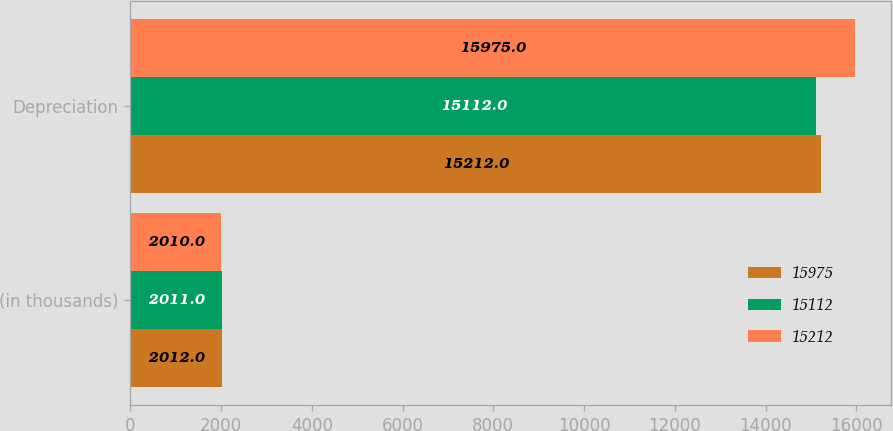Convert chart to OTSL. <chart><loc_0><loc_0><loc_500><loc_500><stacked_bar_chart><ecel><fcel>(in thousands)<fcel>Depreciation<nl><fcel>15975<fcel>2012<fcel>15212<nl><fcel>15112<fcel>2011<fcel>15112<nl><fcel>15212<fcel>2010<fcel>15975<nl></chart> 